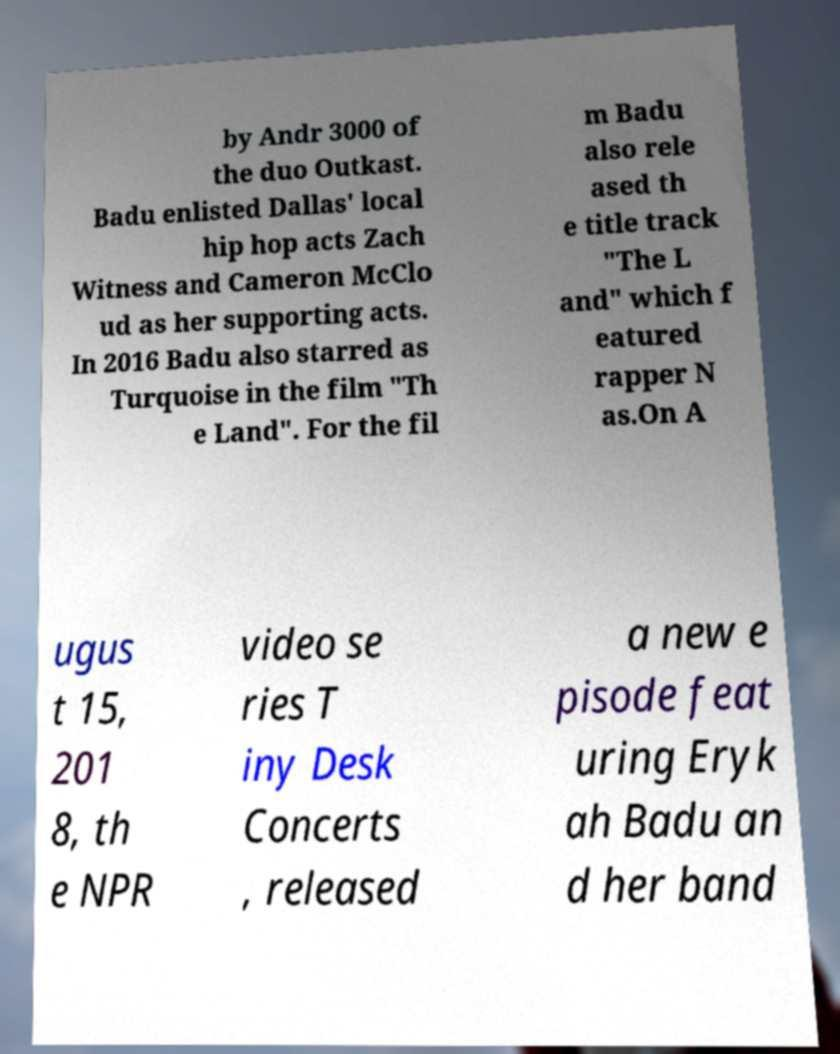Can you read and provide the text displayed in the image?This photo seems to have some interesting text. Can you extract and type it out for me? by Andr 3000 of the duo Outkast. Badu enlisted Dallas' local hip hop acts Zach Witness and Cameron McClo ud as her supporting acts. In 2016 Badu also starred as Turquoise in the film "Th e Land". For the fil m Badu also rele ased th e title track "The L and" which f eatured rapper N as.On A ugus t 15, 201 8, th e NPR video se ries T iny Desk Concerts , released a new e pisode feat uring Eryk ah Badu an d her band 